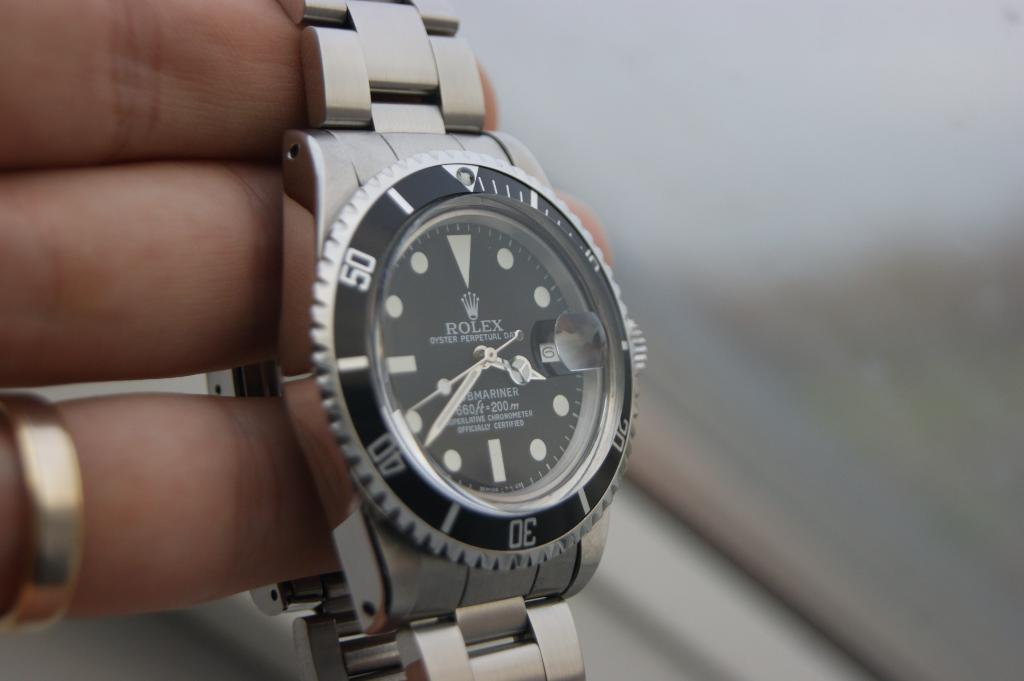<image>
Share a concise interpretation of the image provided. Someone wearing a wedding band holds a Rolex watch. 